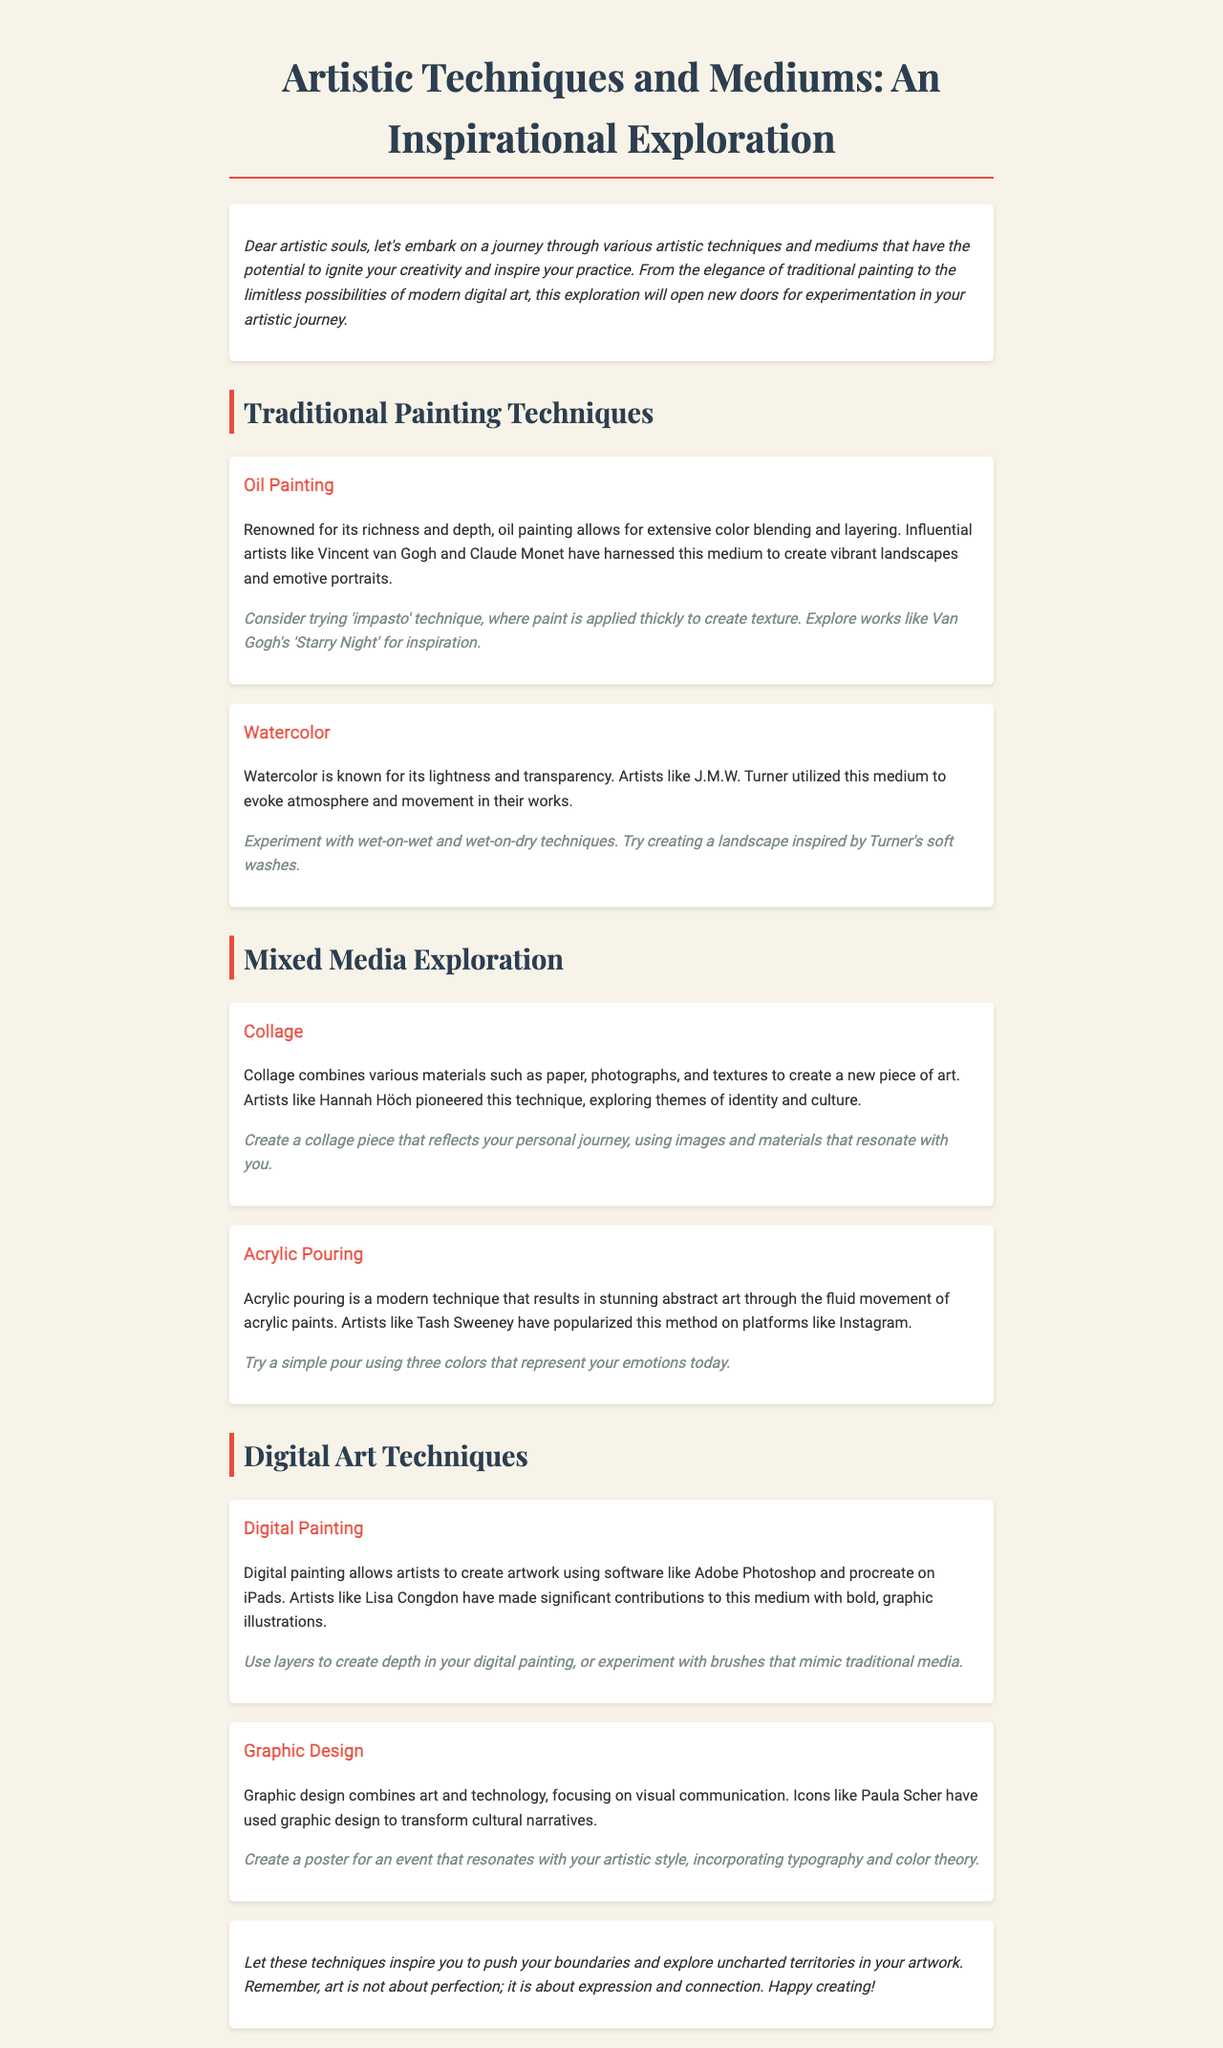what is the title of the newsletter? The title of the newsletter is the main heading located at the top of the document.
Answer: Artistic Techniques and Mediums: An Inspirational Exploration who are two artists mentioned in the oil painting section? The document provides examples of artists specifically associated with oil painting techniques.
Answer: Vincent van Gogh and Claude Monet what technique can be tried in watercolor painting? The document describes specific techniques that can be explored in watercolor painting.
Answer: wet-on-wet and wet-on-dry techniques which modern technique is highlighted in the mixed media section? The document mentions a specific modern technique that results in abstract art.
Answer: Acrylic Pouring who is an influential figure in graphic design mentioned in the newsletter? The document identifies key figures within the field of graphic design based on their contributions.
Answer: Paula Scher what is the main focus of digital painting? The document explains the primary activity involved in the digital painting technique.
Answer: creating artwork using software what should you create that reflects your personal journey in collage art? The newsletter suggests what kind of work to produce using the collage technique.
Answer: a collage piece what is emphasized as the purpose of art in the conclusion? The conclusion elaborates on the broader meaning of artistic expression.
Answer: expression and connection 